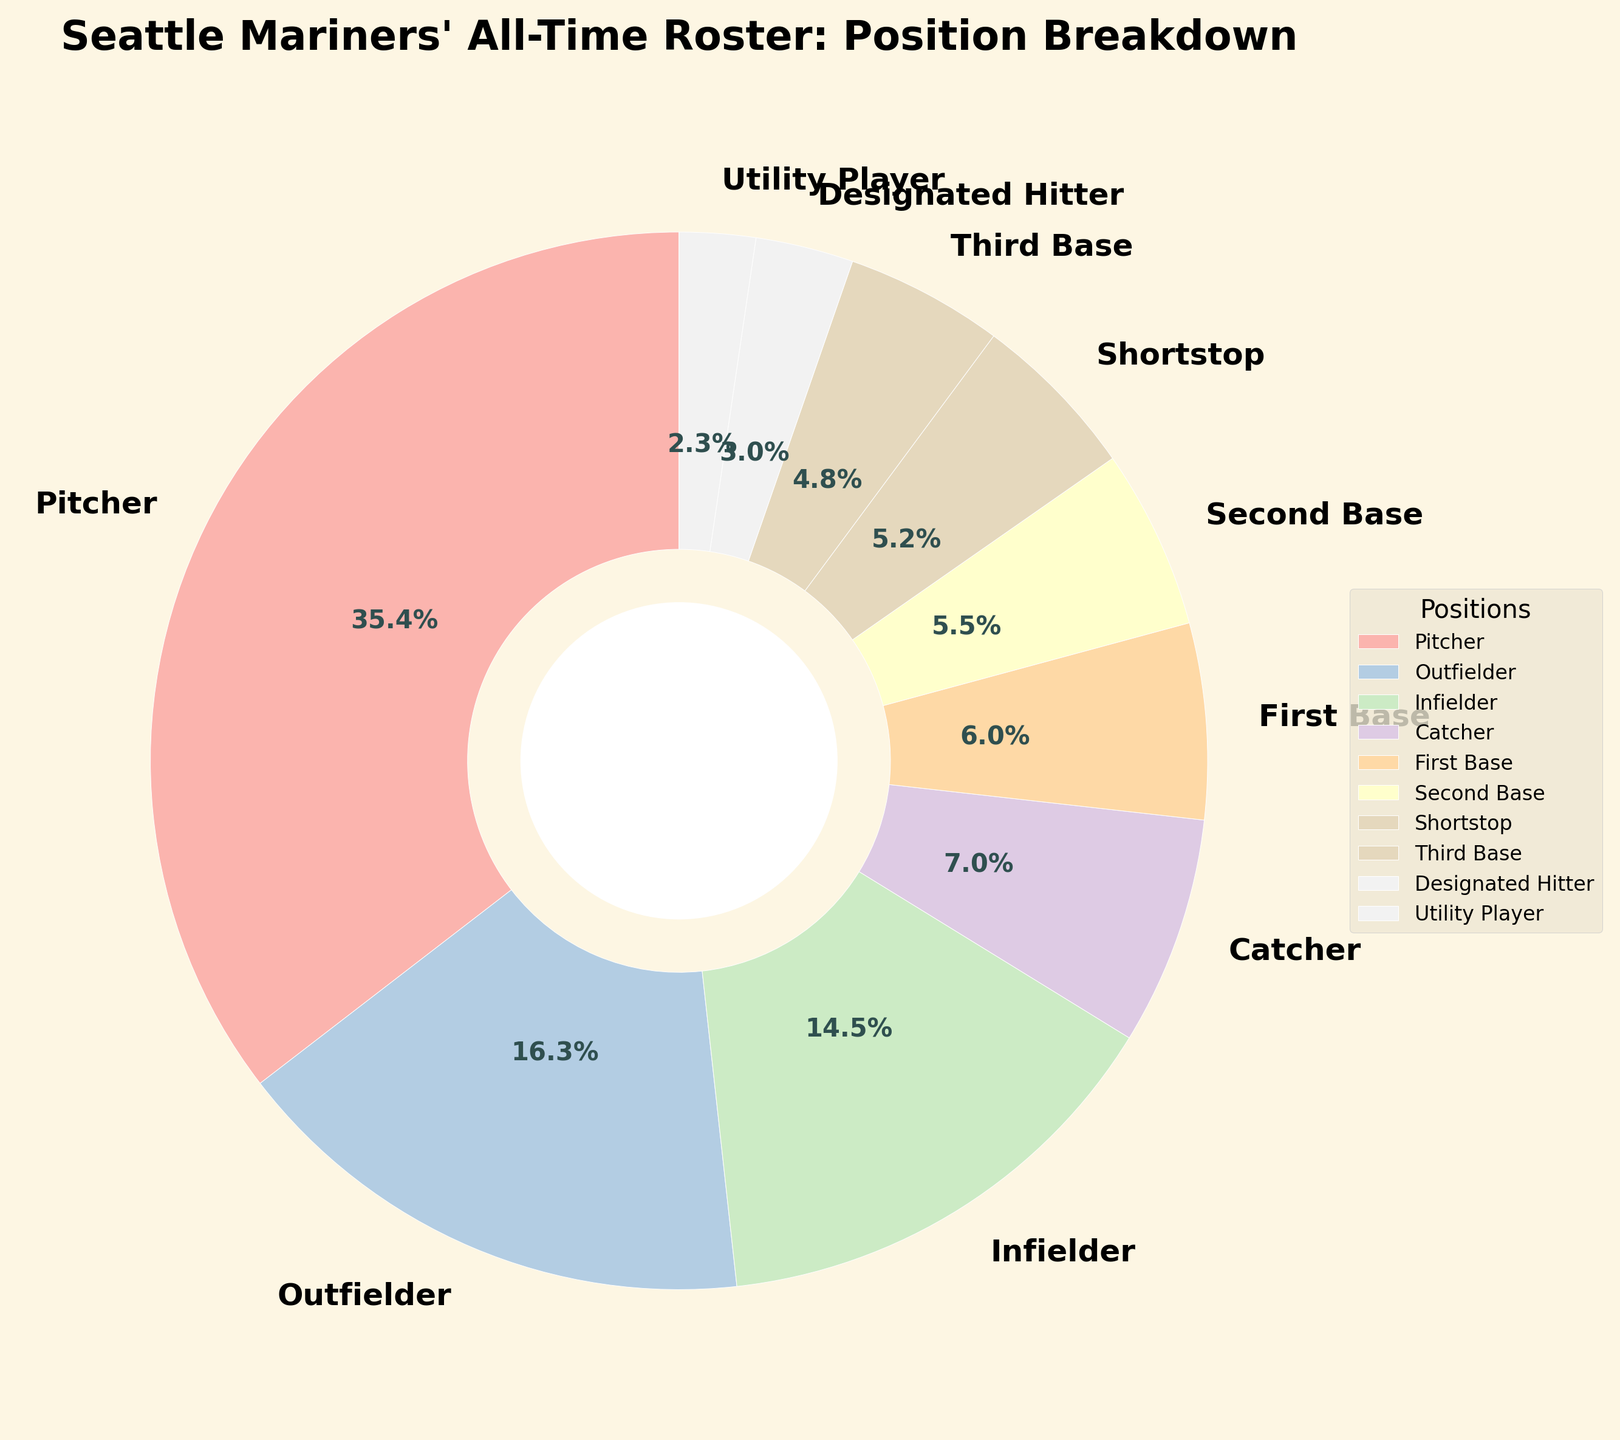What percentage of the Seattle Mariners' all-time roster consists of Pitchers? The chart shows the breakdown of baseball player positions in percentages. The section labeled "Pitcher" represents 213 players.
Answer: 44.0% Which position has the smallest representation on the chart? By observing the pie chart, the smallest section corresponds to the category "Utility Player" with 14 players.
Answer: Utility Player How many more Pitchers are there than Outfielders? The chart indicates there are 213 Pitchers and 98 Outfielders. The difference is calculated as 213 - 98.
Answer: 115 Compare the representation between Infielders and Catchers. Which is higher? The chart indicates there are 87 Infielders and 42 Catchers. Since 87 is greater than 42, Infielders have a higher representation.
Answer: Infielders Which positions constitute at least 10% of the roster each? The pie chart shows two sections that represent more than 10% each: Pitchers (213 players) and Outfielders (98 players). Given the total number of players, their percentages translate to above 10%.
Answer: Pitcher, Outfielder What visual attribute differentiates the Utility Player section from other sections? By examining the visual styles in the pie chart, the Utility Player section uses a distinct color separate from other sections which contributes to its visual difference.
Answer: Color 